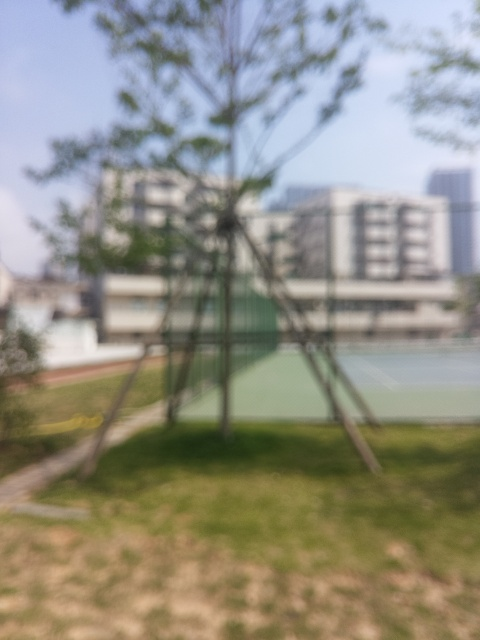What is the color variation in the image?
A. Colorful variation
B. Vibrant colors
C. Monotonous colors
D. Contrasting colors
Answer with the option's letter from the given choices directly. While the image is blurred and specific colors are not distinctly visible, the overall impression does not suggest vibrant or contrasting colors. One might say the colors appear somewhat muted or monotonous, albeit it's difficult to ascertain due to the lack of focus. Therefore, a more cautious response might be to refrain from definitive categorization of color variation without a clearer image. 